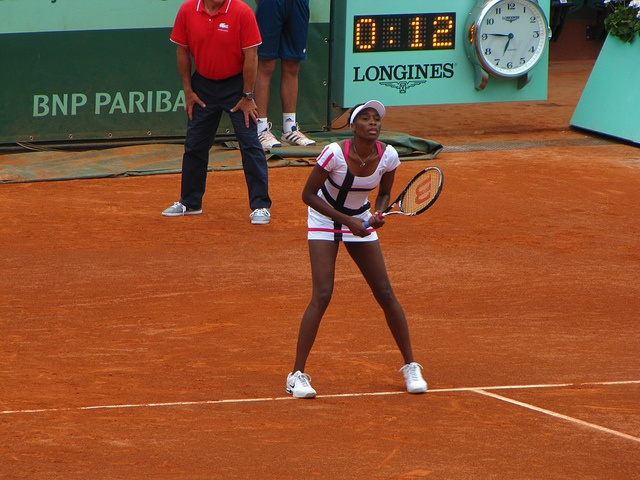Describe the objects in this image and their specific colors. I can see people in green, maroon, black, brown, and lavender tones, people in green, black, brown, and maroon tones, clock in green, darkgray, teal, and lightblue tones, clock in green, black, maroon, and gray tones, and tennis racket in green, brown, salmon, black, and tan tones in this image. 